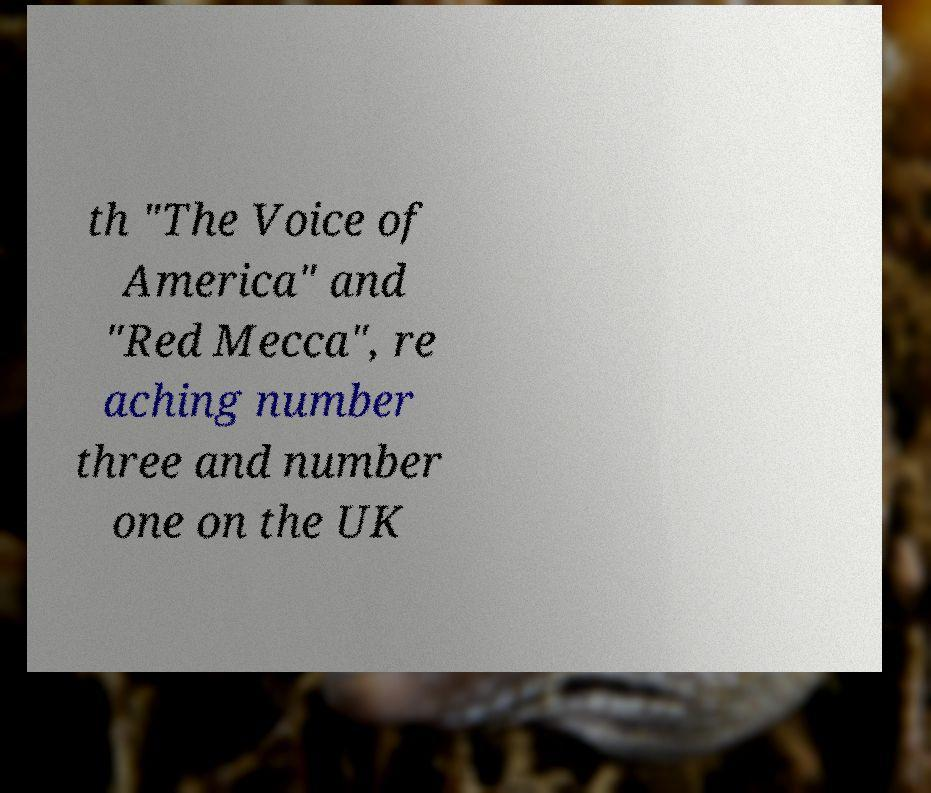Please read and relay the text visible in this image. What does it say? th "The Voice of America" and "Red Mecca", re aching number three and number one on the UK 